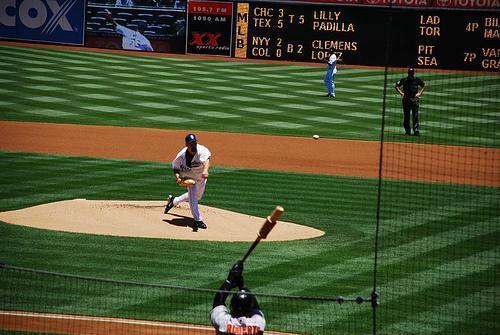How many people are pictured here?
Give a very brief answer. 4. How many people are wearing black?
Give a very brief answer. 1. 